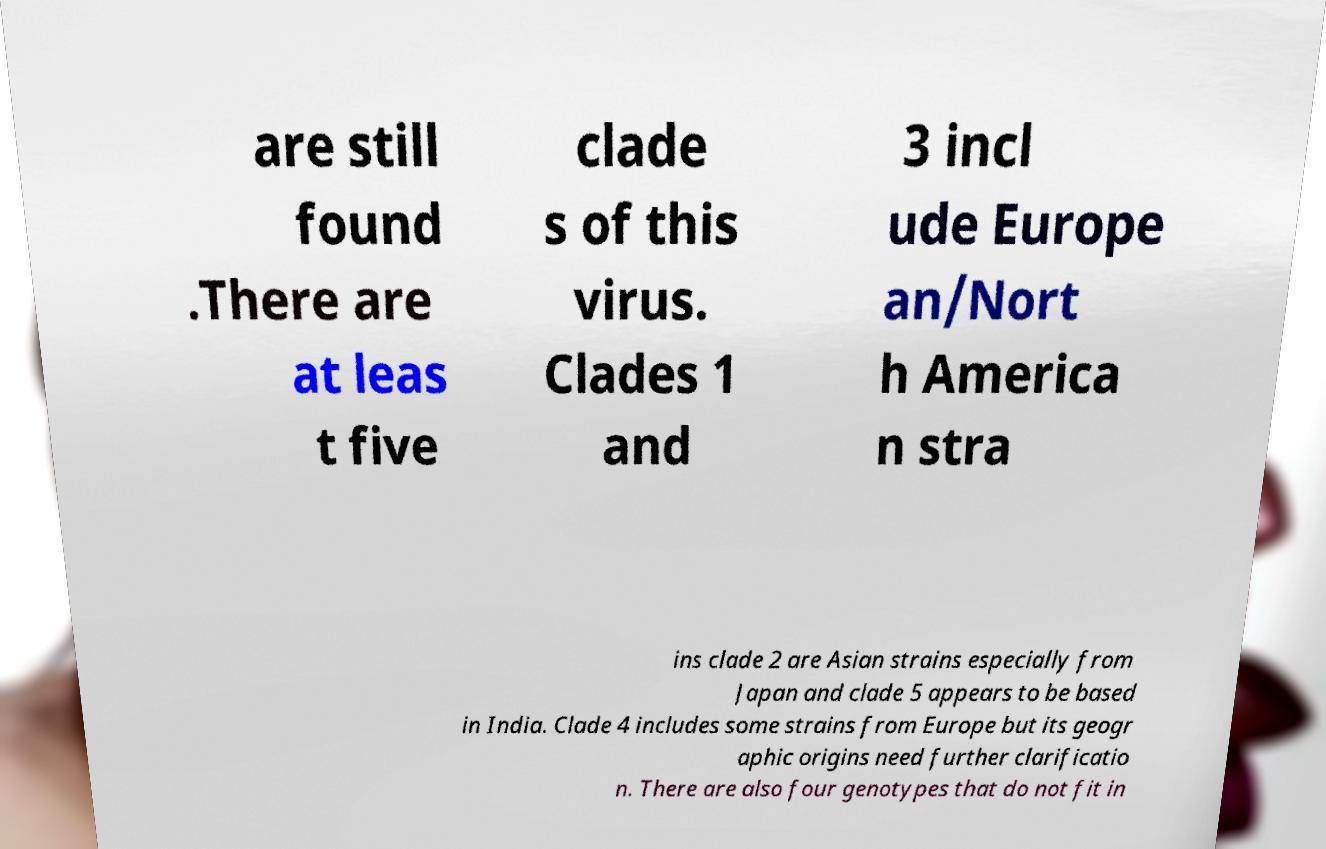What messages or text are displayed in this image? I need them in a readable, typed format. are still found .There are at leas t five clade s of this virus. Clades 1 and 3 incl ude Europe an/Nort h America n stra ins clade 2 are Asian strains especially from Japan and clade 5 appears to be based in India. Clade 4 includes some strains from Europe but its geogr aphic origins need further clarificatio n. There are also four genotypes that do not fit in 